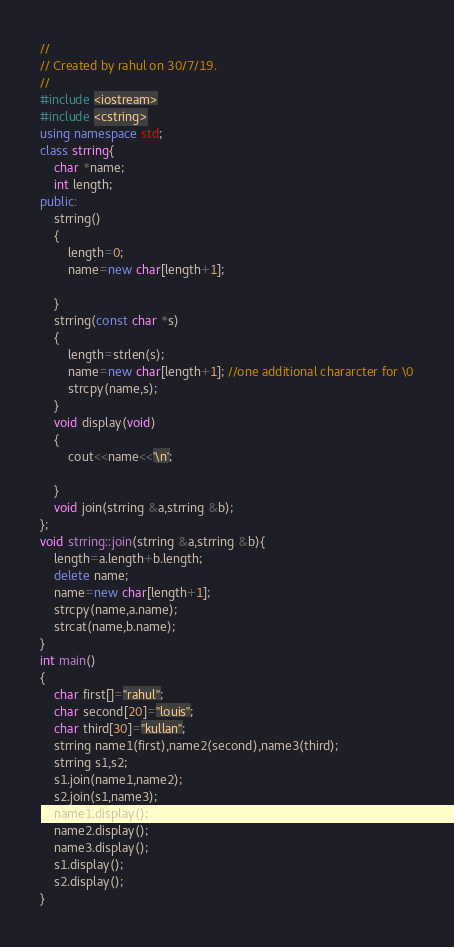<code> <loc_0><loc_0><loc_500><loc_500><_C++_>//
// Created by rahul on 30/7/19.
//
#include <iostream>
#include <cstring>
using namespace std;
class strring{
    char *name;
    int length;
public:
    strring()
    {
        length=0;
        name=new char[length+1];
        
    }
    strring(const char *s)
    {
        length=strlen(s);
        name=new char[length+1]; //one additional chararcter for \0
        strcpy(name,s);
    }
    void display(void)
    {
        cout<<name<<'\n';
        
    }
    void join(strring &a,strring &b);
};
void strring::join(strring &a,strring &b){
    length=a.length+b.length;
    delete name;
    name=new char[length+1];
    strcpy(name,a.name);
    strcat(name,b.name);
}
int main()
{
    char first[]="rahul";
    char second[20]="louis";
    char third[30]="kullan";
    strring name1(first),name2(second),name3(third);
    strring s1,s2;
    s1.join(name1,name2);
    s2.join(s1,name3);
    name1.display();
    name2.display();
    name3.display();
    s1.display();
    s2.display();
}
</code> 